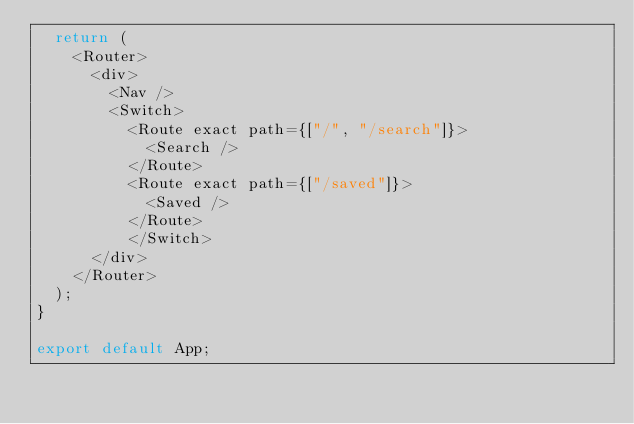Convert code to text. <code><loc_0><loc_0><loc_500><loc_500><_JavaScript_>  return (
    <Router>
      <div>
        <Nav />
        <Switch>
          <Route exact path={["/", "/search"]}>
            <Search />
          </Route>
          <Route exact path={["/saved"]}>
            <Saved />
          </Route>
          </Switch>
      </div>
    </Router>
  );
}

export default App;</code> 